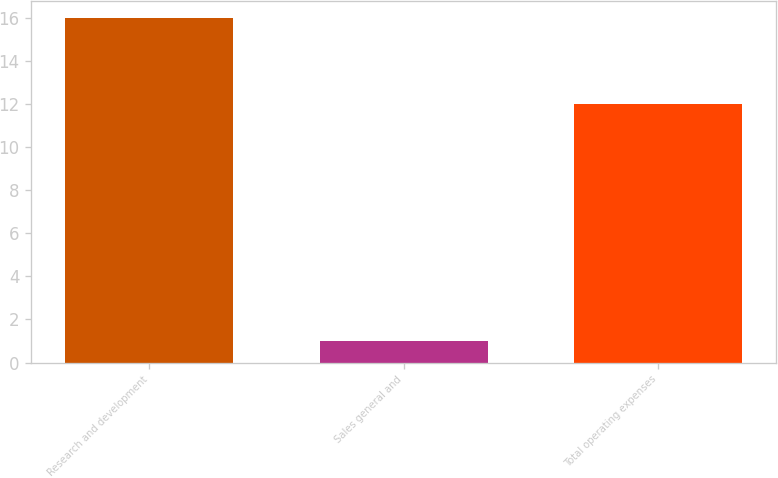<chart> <loc_0><loc_0><loc_500><loc_500><bar_chart><fcel>Research and development<fcel>Sales general and<fcel>Total operating expenses<nl><fcel>16<fcel>1<fcel>12<nl></chart> 